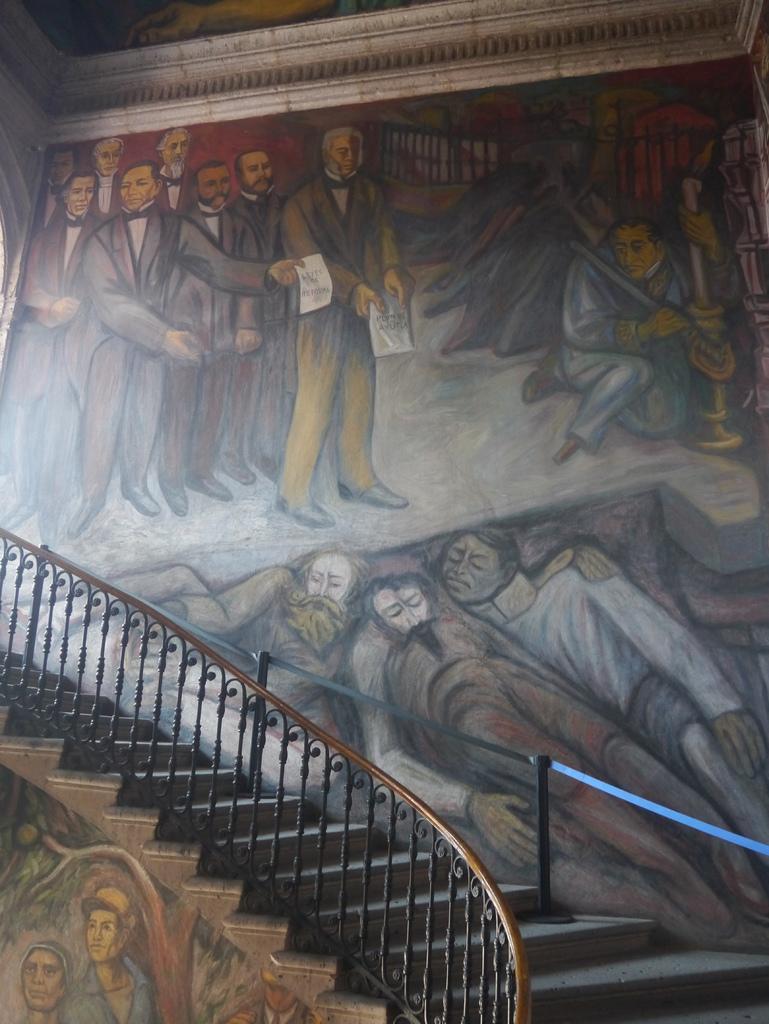In one or two sentences, can you explain what this image depicts? In this picture we can observe stairs and railing. We can observe a wall on which there is a painting of a man standing. Some of them were holding papers. We can observe three men laying here. 